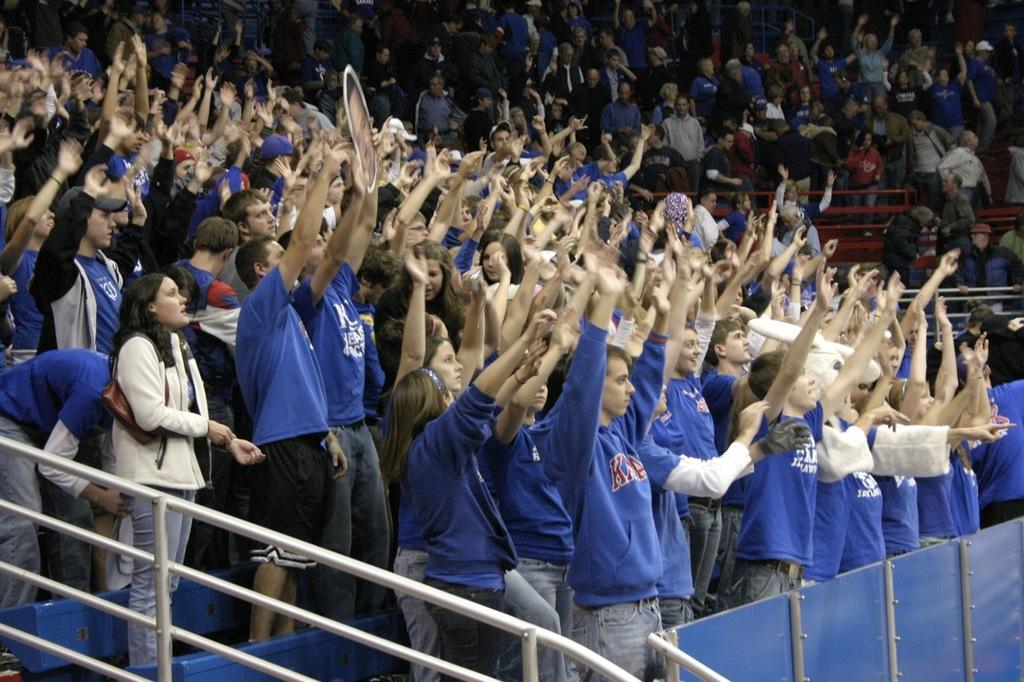What can be seen in the image in terms of people? There are groups of people standing in the image. What type of structures are present at the bottom of the image? There are iron grilles and boards at the bottom of the image. What type of pot is being used to control the flow of water in the image? There is no pot or water present in the image, so it is not possible to determine if any control is being exerted over water flow. 